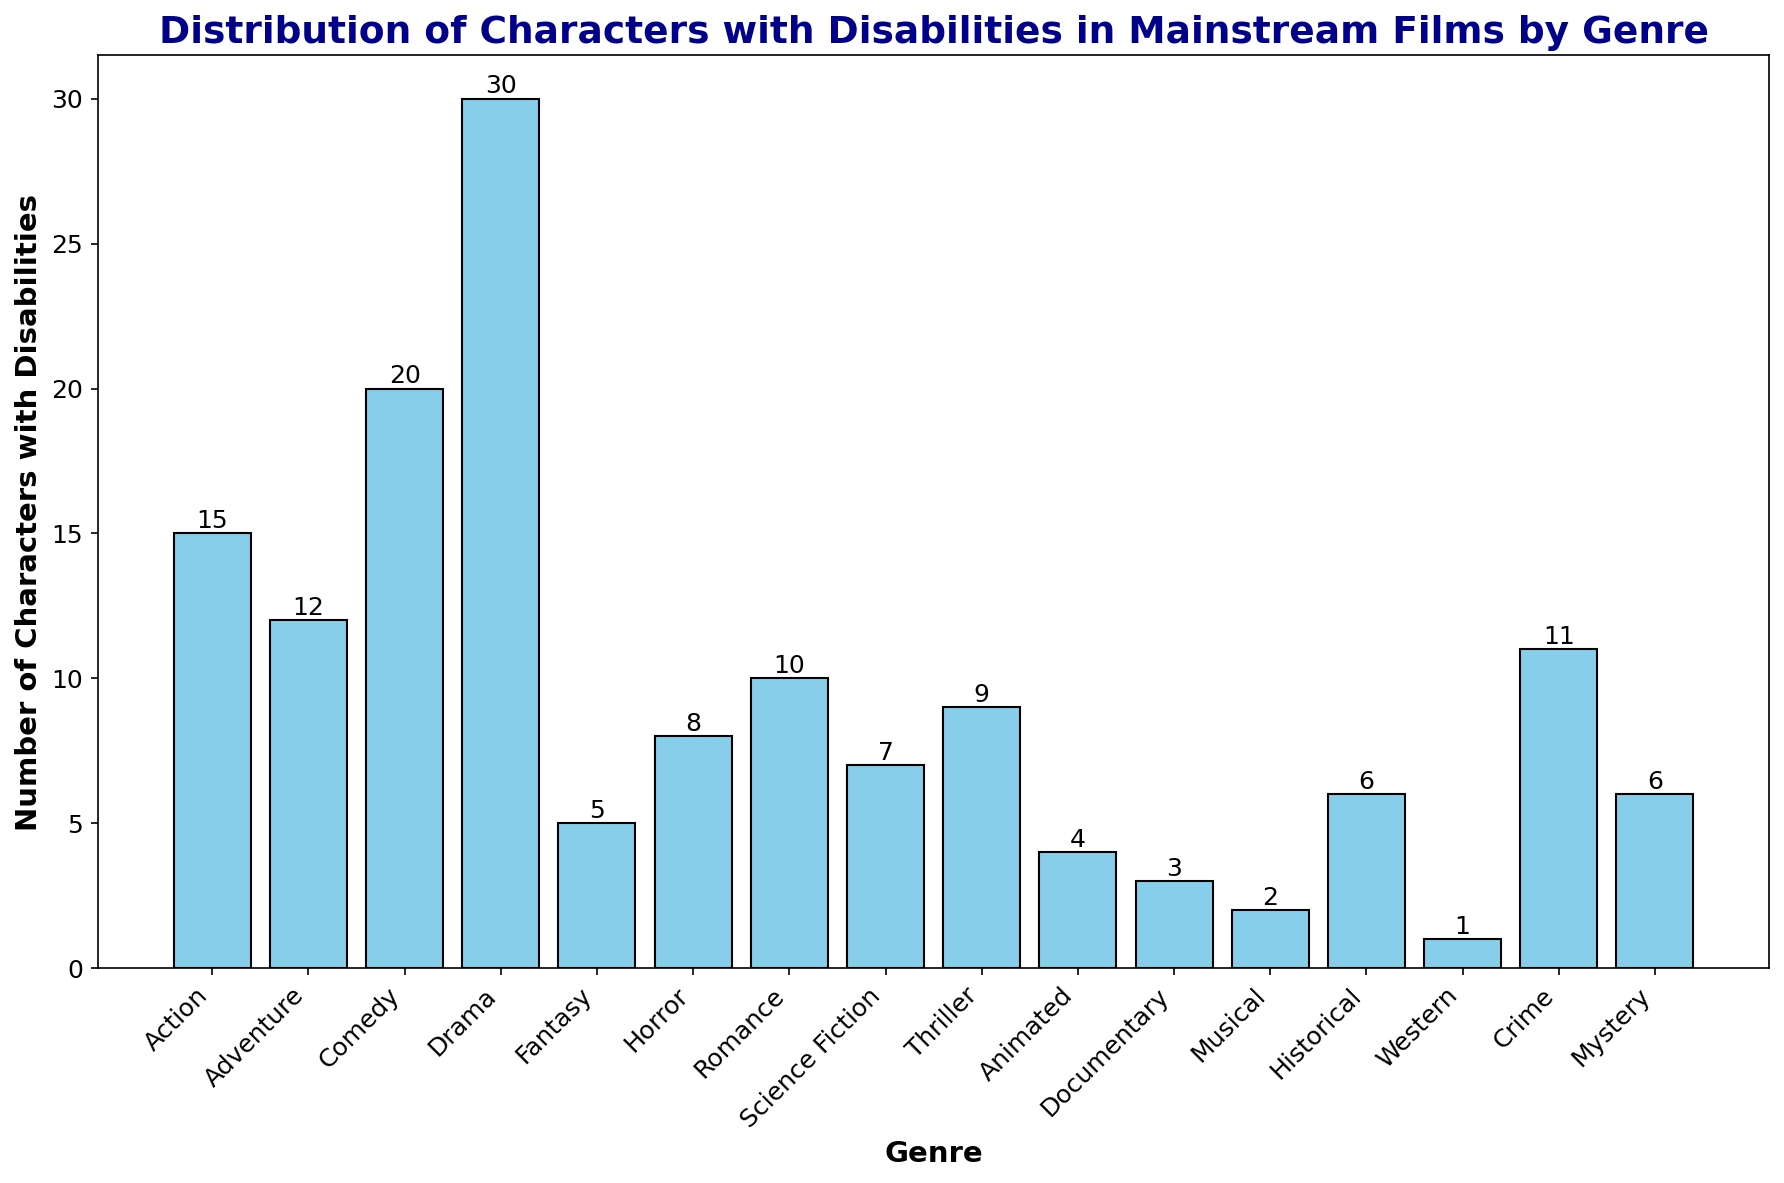Which genre has the highest number of characters with disabilities? By looking at the heights of the bars, the 'Drama' genre has the tallest bar, indicating the highest number.
Answer: Drama How many more characters with disabilities are there in Drama compared to Action? The bar for Drama is at 30 while Action is at 15. The difference is 30 - 15.
Answer: 15 What is the total number of characters with disabilities in Animated, Documentary, and Musical films combined? Summing the heights of the bars: 4 (Animated) + 3 (Documentary) + 2 (Musical) = 9.
Answer: 9 Which genre has the fewest characters with disabilities? By looking at the shortest bar, the 'Western' genre has the smallest value, indicating the fewest characters.
Answer: Western What is the median number of characters with disabilities across all genres? To find the median, list the numbers in ascending order and find the middle value: {1, 2, 3, 4, 5, 6, 7, 8, 9, 10, 11, 12, 15, 20, 30}. The median is the 8th value in this ordered list.
Answer: 10 How many genres have more than 10 characters with disabilities? By counting the number of bars that exceed the height of 10: Action, Comedy, Drama, Crime (4 genres).
Answer: 4 Which genres have fewer than 6 characters with disabilities? By checking bars below the height of 6: Fantasy, Animated, Documentary, Musical, Western (5 genres).
Answer: Fantasy, Animated, Documentary, Musical, Western What is the difference in the number of characters with disabilities between Science Fiction and Romance? The Science Fiction bar is at 7 and the Romance bar is at 10. The difference is 10 - 7.
Answer: 3 Which genre's bar is approximately half the height of Comedy's bar? Comedy has a height of 20. Approximately half of 20 is 10. The closest bar to this height is Romance with a height of 10.
Answer: Romance 